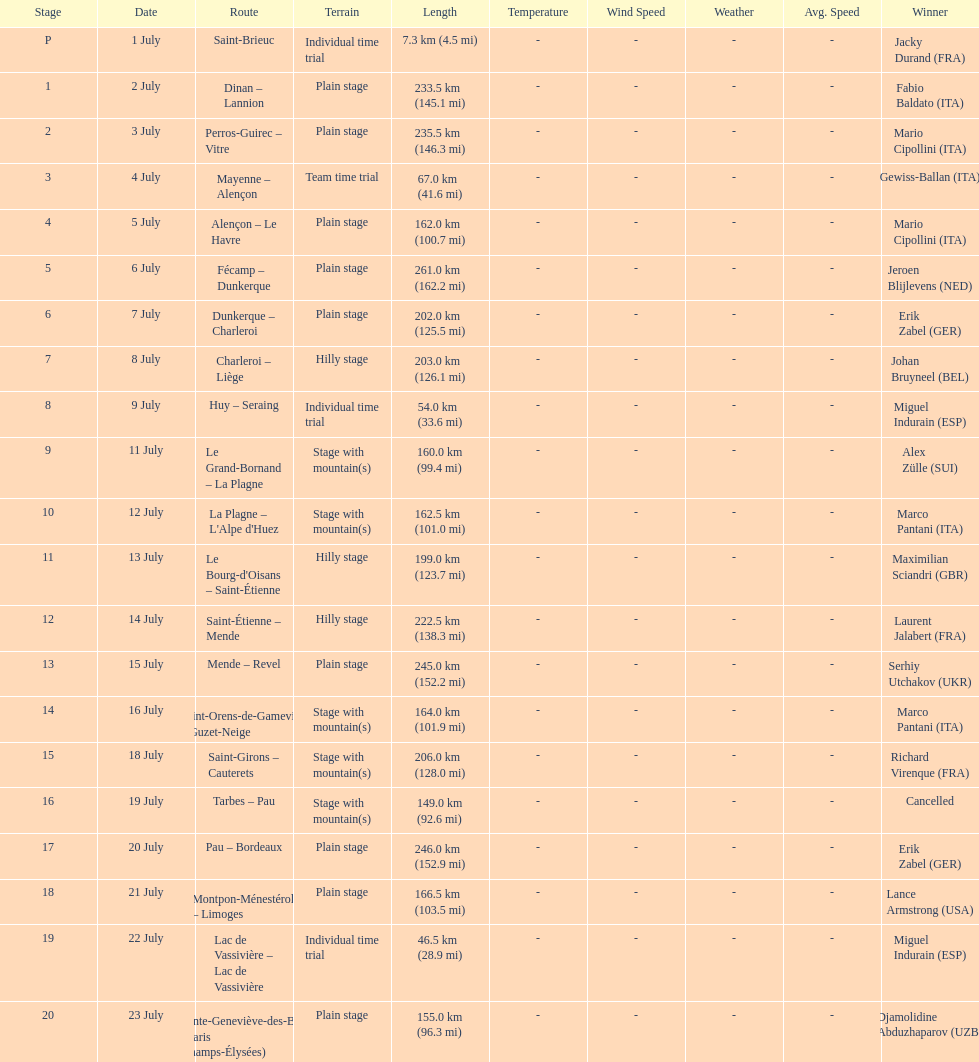After lance armstrong, who led next in the 1995 tour de france? Miguel Indurain. 